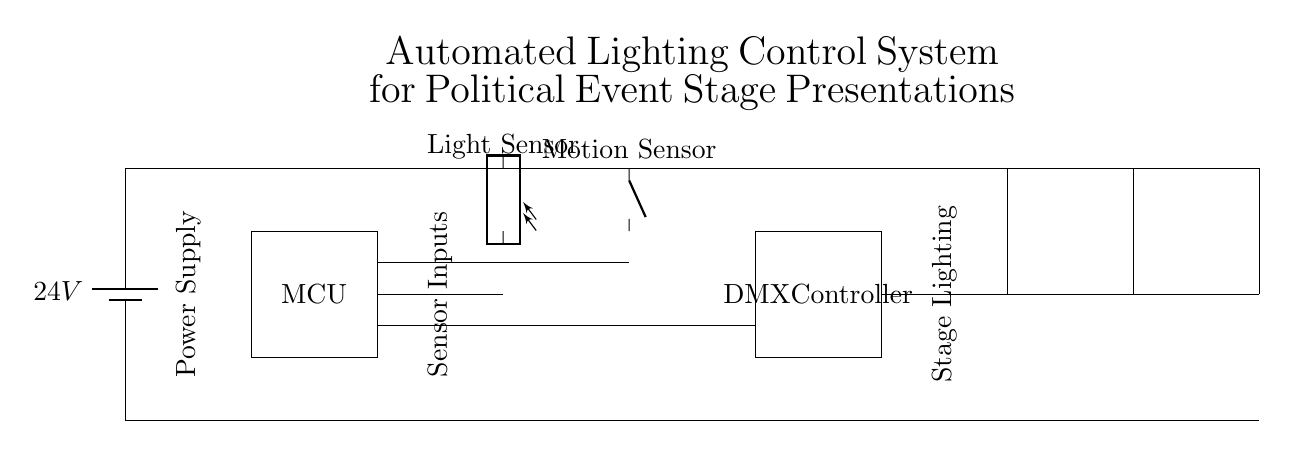What is the voltage of the power supply? The voltage of the power supply is indicated next to the battery symbol, which shows 24 volts.
Answer: 24 volts What type of microcontroller is used? The circuit diagram does not specify a type but labels it simply as "MCU" (Microcontroller Unit).
Answer: MCU How many stage lights are connected in the circuit? The circuit diagram shows three stage lights labeled as Stage Light 1, Stage Light 2, and Stage Light 3, indicating their presence in the system.
Answer: Three What sensors are included in this control system? The circuit includes a light sensor and a motion sensor, which are positioned on the left side of the microcontroller in the diagram.
Answer: Light sensor and motion sensor What is the function of the DMX controller in this system? The DMX controller is responsible for controlling the stage lighting, acting as a communication protocol for lighting devices, enabling dynamic lighting settings.
Answer: Control stage lighting Which components directly interact with the microcontroller? The components that directly interact with the microcontroller are the light sensor and motion sensor, which provide input data for controlling the stage lights.
Answer: Light sensor and motion sensor How does the power supply connect to the stage lights? The power supply connects to the stage lights through the microcontroller and the DMX controller, integrating power flow to enable control over the lights.
Answer: Through the microcontroller and DMX controller 